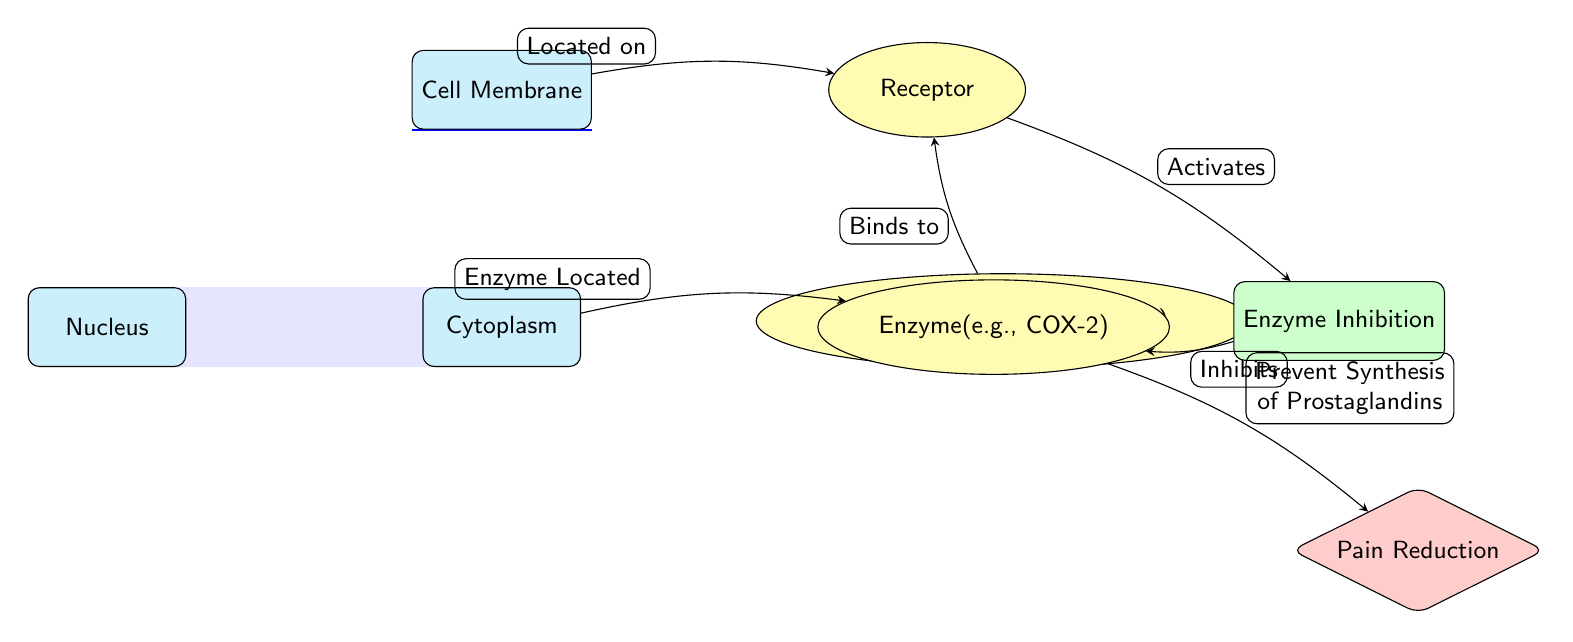What is the position of the receptor in relation to the drug molecule? The receptor is located to the right of the drug molecule, as indicated by the directional flow of the diagram.
Answer: Right What does the drug molecule bind to? The diagram shows an arrow from the drug molecule to the receptor labeled "Binds to," indicating the drug molecule binds to the receptor.
Answer: Receptor How many main components (nodes) are in the diagram? The diagram features a total of five main components, including the nucleus, cytoplasm, cell membrane, receptor, and enzyme, which are distinct entities in the cellular mechanism.
Answer: Five What is the effect of enzyme inhibition in the diagram? The diagram's flow illustrates that enzyme inhibition leads to pain reduction, as shown by the arrow connecting enzyme inhibition to the effect node labeled "Pain Reduction."
Answer: Pain Reduction What is the function of the drug molecule (e.g., Ibuprofen) according to the diagram? The diagram represents the drug molecule's role in inhibiting an enzyme and subsequently preventing the synthesis of prostaglandins, which is indicative of its pain-relieving properties.
Answer: Inhibits enzyme activity How does the receptor influence the enzyme according to the diagram? The diagram illustrates that once the receptor is activated by the drug molecule, it influences the process of enzyme inhibition, which subsequently inhibits the enzyme's activity, leading to the prevention of prostaglandin synthesis.
Answer: Activates enzyme inhibition What cellular component is located on the cell membrane? The diagram explicitly notes that the receptor is located on the cell membrane, as indicated by the arrow connecting the cell membrane to the receptor labeled "Located on."
Answer: Receptor What molecules or components are involved in the pain reduction pathway illustrated in the diagram? By examining the flows in the diagram, the pathway involves the drug molecule, the receptor, the process of enzyme inhibition, and the final effect of pain reduction, illustrating a clearly defined biochemical pathway.
Answer: Drug molecule, receptor, enzyme inhibition, enzyme What is the relationship between the enzyme and prostaglandins? The relationship is demonstrated in the diagram by showing that the enzyme's inhibition prevents the synthesis of prostaglandins, which are notable for their role in conveying pain.
Answer: Prevent Synthesis of Prostaglandins 